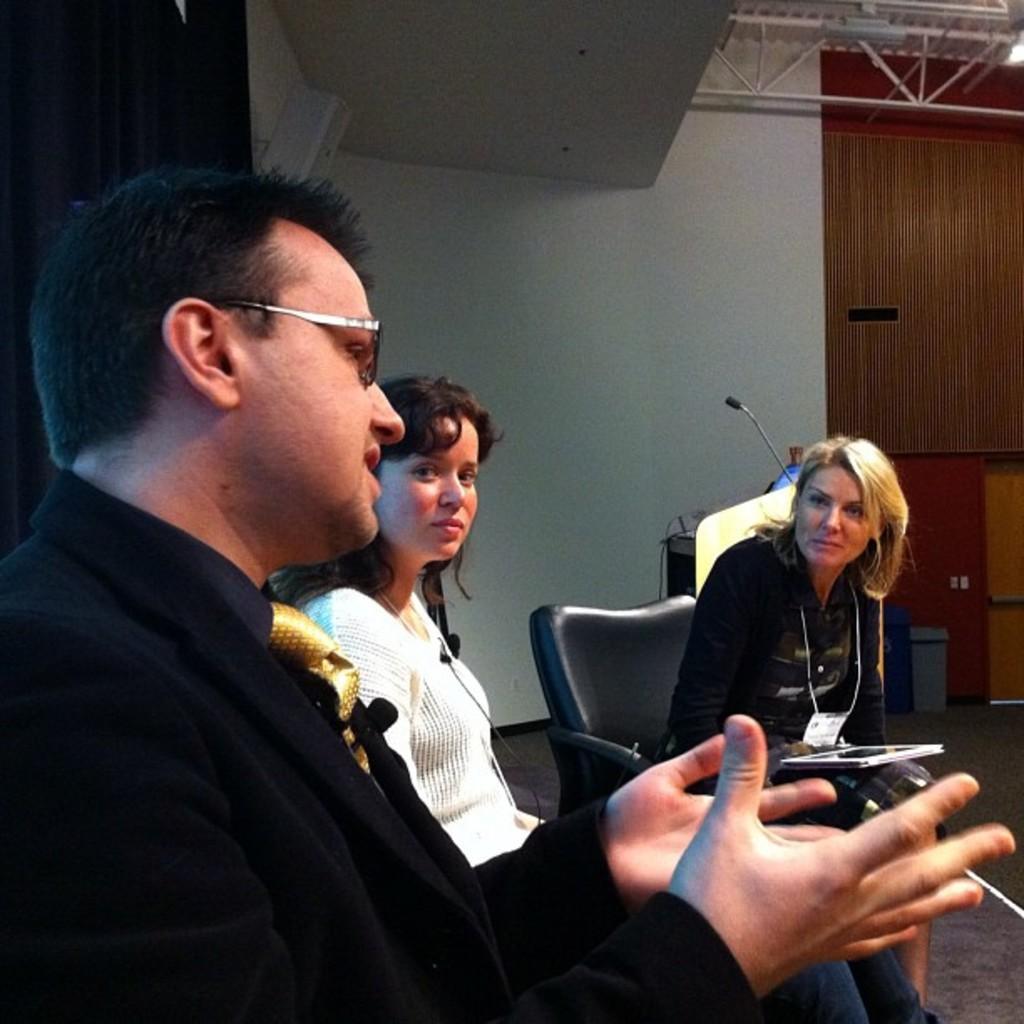Please provide a concise description of this image. In this image there are three persons discussing in between them and at the top of the image there is a fencing attached to the roof. 